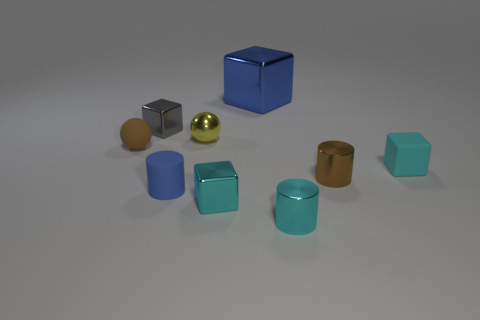Subtract all shiny cylinders. How many cylinders are left? 1 Add 1 big purple rubber balls. How many objects exist? 10 Subtract all brown spheres. How many cyan blocks are left? 2 Subtract all cyan cylinders. How many cylinders are left? 2 Subtract 1 cylinders. How many cylinders are left? 2 Subtract all small gray matte cubes. Subtract all small metallic spheres. How many objects are left? 8 Add 8 blue objects. How many blue objects are left? 10 Add 4 brown balls. How many brown balls exist? 5 Subtract 0 purple blocks. How many objects are left? 9 Subtract all blocks. How many objects are left? 5 